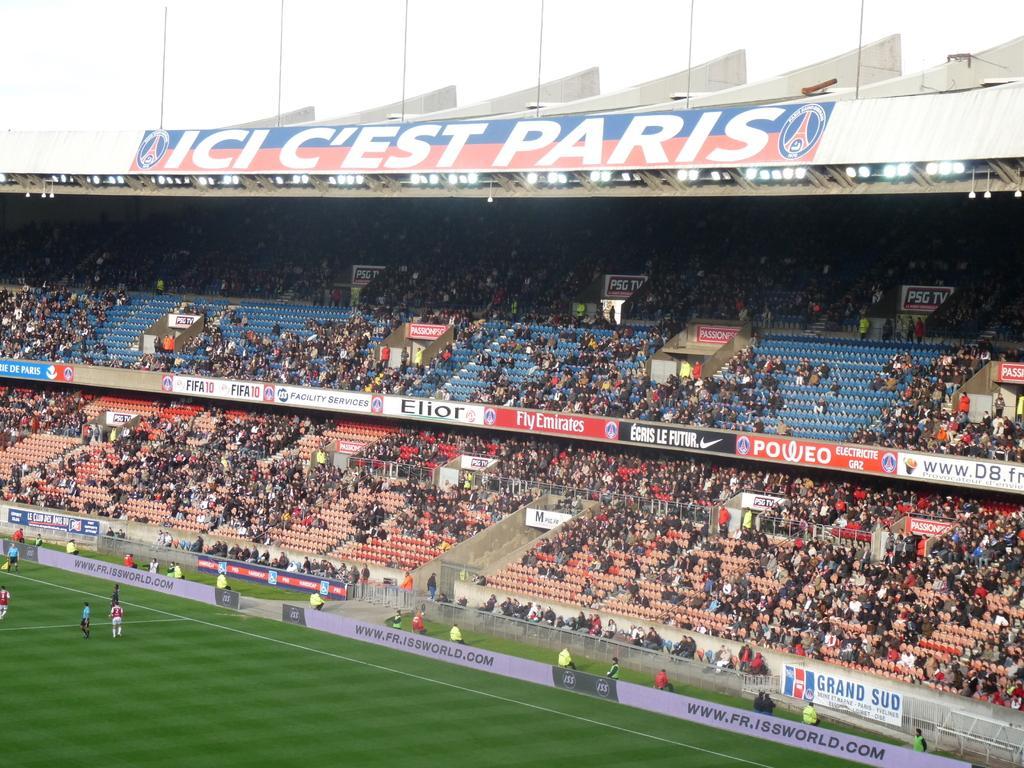Could you give a brief overview of what you see in this image? People are present on the ground. There is a stadium. People are present watching the match. 